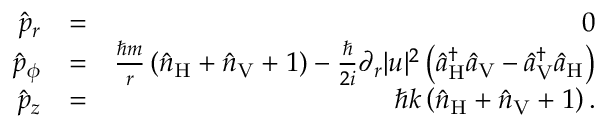<formula> <loc_0><loc_0><loc_500><loc_500>\begin{array} { r l r } { \hat { p } _ { r } } & { = } & { 0 } \\ { \hat { p } _ { \phi } } & { = } & { \frac { \hbar { m } } { r } \left ( \hat { n } _ { H } + \hat { n } _ { V } + 1 \right ) - \frac { } { 2 i } \partial _ { r } | u | ^ { 2 } \left ( \hat { a } _ { H } ^ { \dagger } \hat { a } _ { V } - \hat { a } _ { V } ^ { \dagger } \hat { a } _ { H } \right ) } \\ { \hat { p } _ { z } } & { = } & { \hbar { k } \left ( \hat { n } _ { H } + \hat { n } _ { V } + 1 \right ) . } \end{array}</formula> 